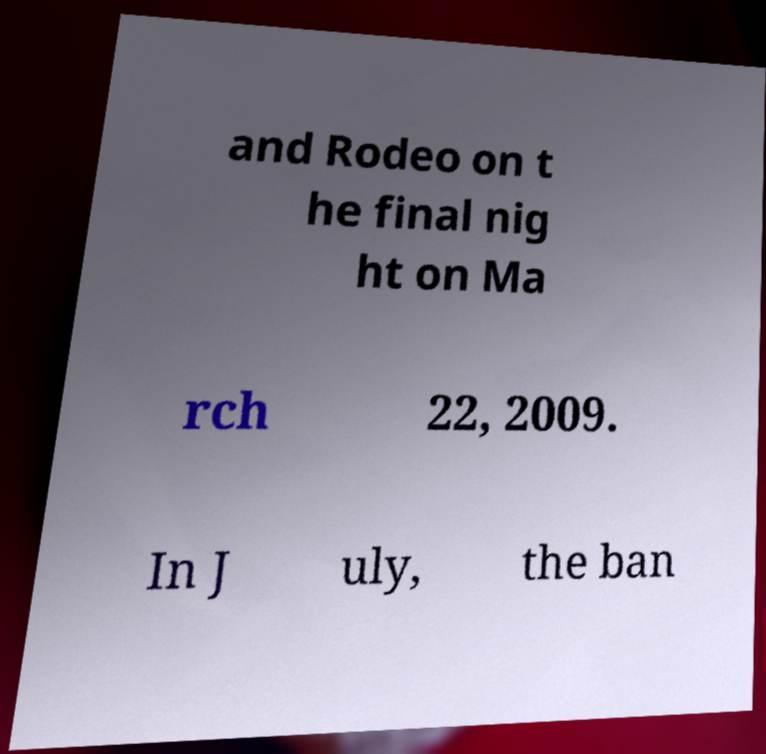Could you extract and type out the text from this image? and Rodeo on t he final nig ht on Ma rch 22, 2009. In J uly, the ban 